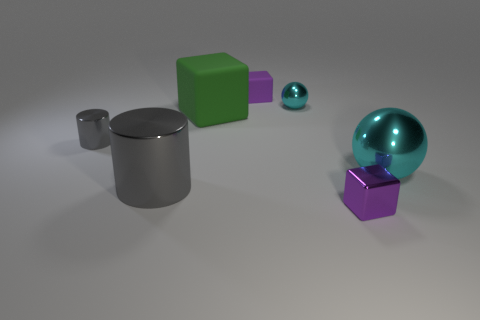Add 2 green matte cubes. How many objects exist? 9 Subtract all balls. How many objects are left? 5 Subtract all cubes. Subtract all small purple metallic blocks. How many objects are left? 3 Add 1 tiny purple rubber things. How many tiny purple rubber things are left? 2 Add 3 small blocks. How many small blocks exist? 5 Subtract 0 red spheres. How many objects are left? 7 